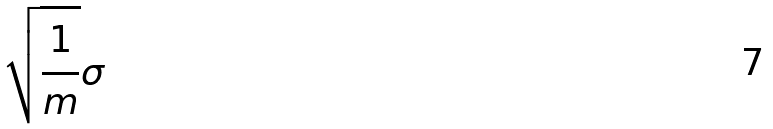<formula> <loc_0><loc_0><loc_500><loc_500>\sqrt { \frac { 1 } { m } } \sigma</formula> 